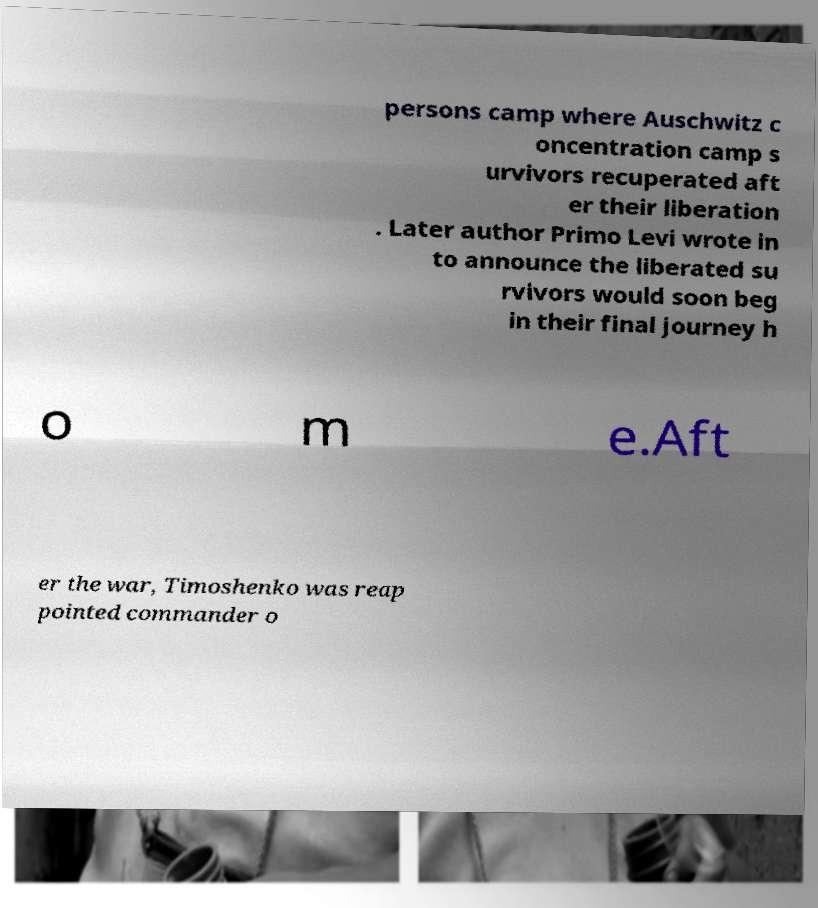For documentation purposes, I need the text within this image transcribed. Could you provide that? persons camp where Auschwitz c oncentration camp s urvivors recuperated aft er their liberation . Later author Primo Levi wrote in to announce the liberated su rvivors would soon beg in their final journey h o m e.Aft er the war, Timoshenko was reap pointed commander o 